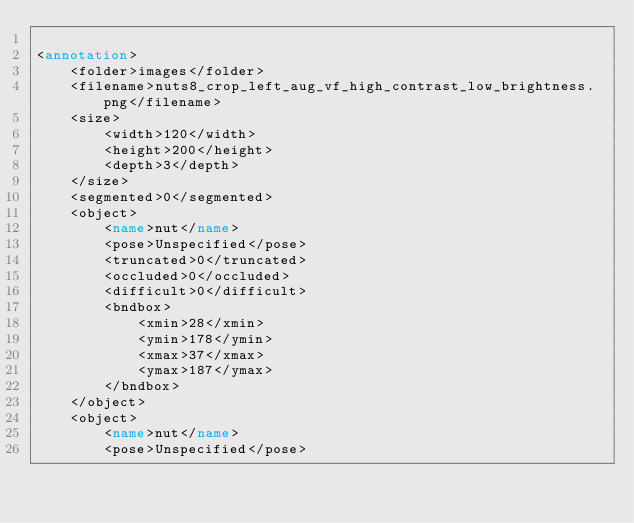<code> <loc_0><loc_0><loc_500><loc_500><_XML_>
<annotation>
    <folder>images</folder>
    <filename>nuts8_crop_left_aug_vf_high_contrast_low_brightness.png</filename>
    <size>
        <width>120</width>
        <height>200</height>
        <depth>3</depth>
    </size>
    <segmented>0</segmented>
    <object>
        <name>nut</name>
        <pose>Unspecified</pose>
        <truncated>0</truncated>
        <occluded>0</occluded>
        <difficult>0</difficult>
        <bndbox>
            <xmin>28</xmin>
            <ymin>178</ymin>
            <xmax>37</xmax>
            <ymax>187</ymax>
        </bndbox>
    </object>
    <object>
        <name>nut</name>
        <pose>Unspecified</pose></code> 